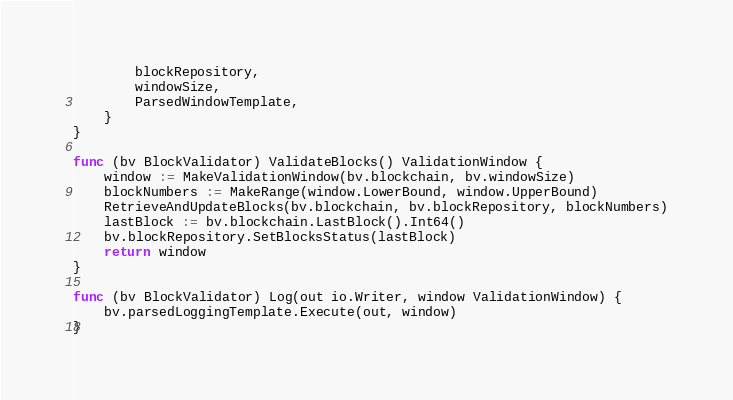<code> <loc_0><loc_0><loc_500><loc_500><_Go_>		blockRepository,
		windowSize,
		ParsedWindowTemplate,
	}
}

func (bv BlockValidator) ValidateBlocks() ValidationWindow {
	window := MakeValidationWindow(bv.blockchain, bv.windowSize)
	blockNumbers := MakeRange(window.LowerBound, window.UpperBound)
	RetrieveAndUpdateBlocks(bv.blockchain, bv.blockRepository, blockNumbers)
	lastBlock := bv.blockchain.LastBlock().Int64()
	bv.blockRepository.SetBlocksStatus(lastBlock)
	return window
}

func (bv BlockValidator) Log(out io.Writer, window ValidationWindow) {
	bv.parsedLoggingTemplate.Execute(out, window)
}</code> 